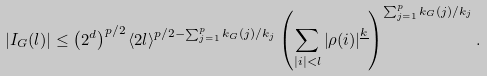Convert formula to latex. <formula><loc_0><loc_0><loc_500><loc_500>\left | I _ { G } ( l ) \right | \leq \left ( 2 ^ { d } \right ) ^ { p / 2 } \langle 2 l \rangle ^ { p / 2 - \sum _ { j = 1 } ^ { p } k _ { G } ( j ) / k _ { j } } \left ( \sum _ { | i | < l } \left | \rho ( i ) \right | ^ { \underline { k } } \right ) ^ { \sum _ { j = 1 } ^ { p } k _ { G } ( j ) / k _ { j } } .</formula> 